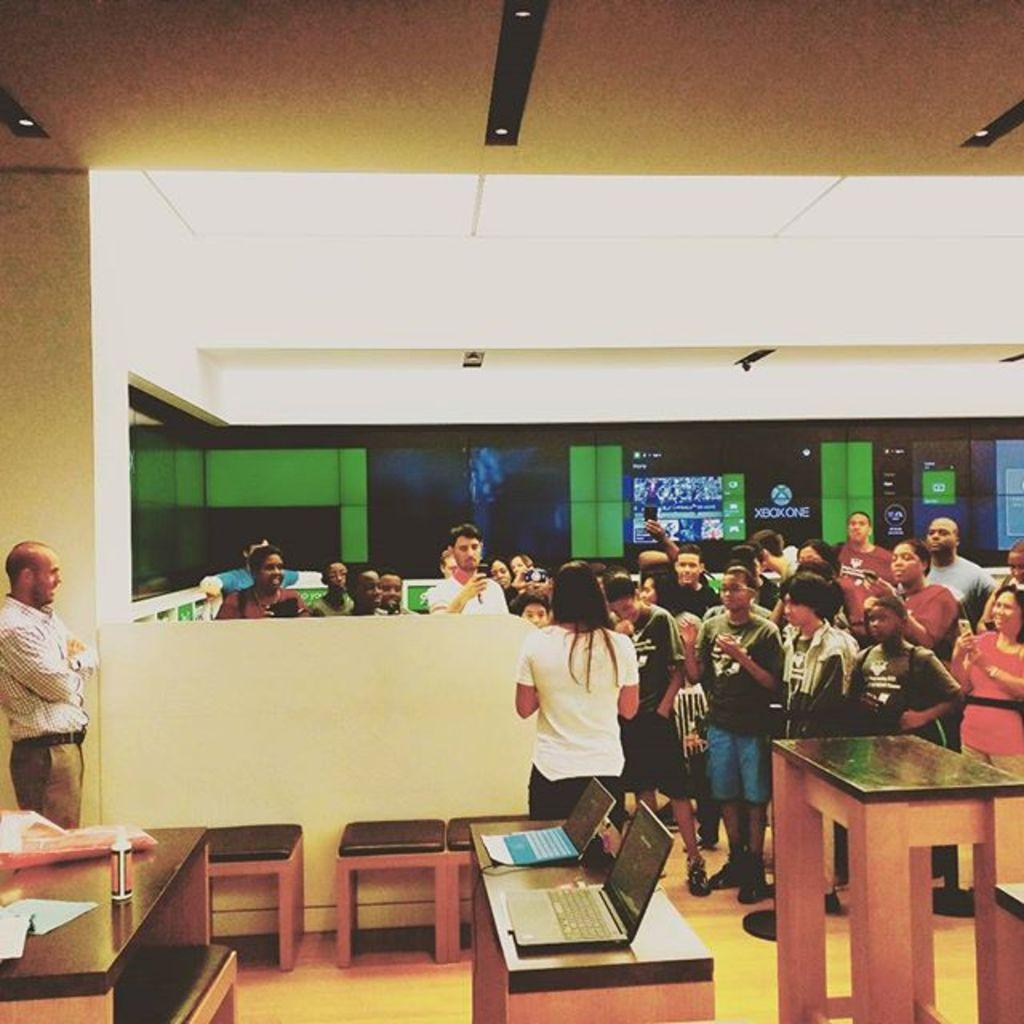What are the people in the image doing? There is a group of people standing on the floor. What is on the table in the image? There are laptops on the table, as well as other objects. Can you describe the lighting in the image? There is a light in the image. What type of zipper can be seen on the table in the image? There is no zipper present on the table in the image. What causes the people in the image to laugh? The image does not show the people laughing, so we cannot determine the cause of their laughter. 